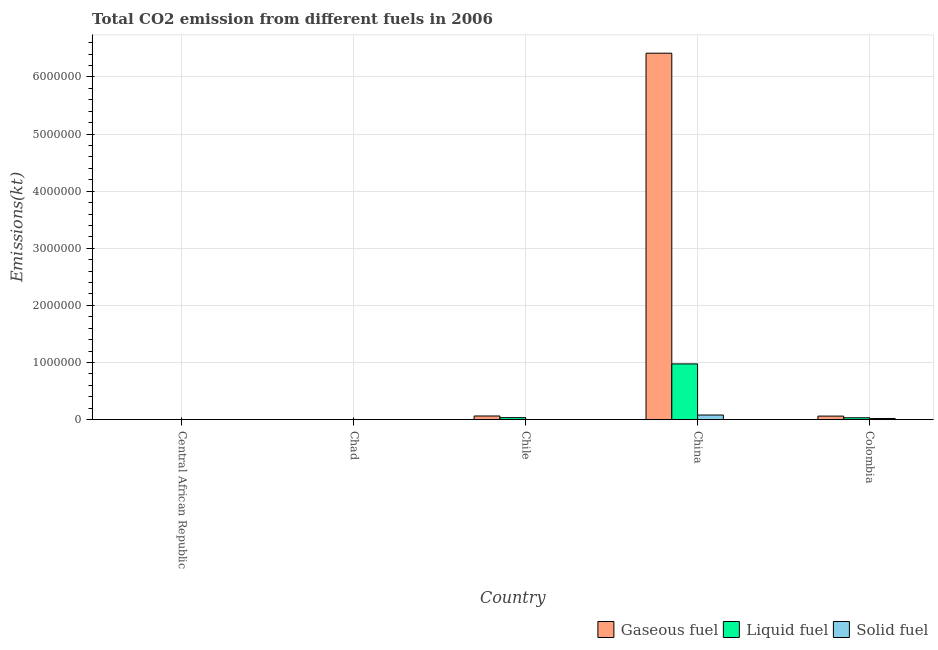How many different coloured bars are there?
Provide a short and direct response. 3. How many groups of bars are there?
Ensure brevity in your answer.  5. Are the number of bars per tick equal to the number of legend labels?
Offer a very short reply. Yes. How many bars are there on the 1st tick from the left?
Give a very brief answer. 3. How many bars are there on the 4th tick from the right?
Make the answer very short. 3. What is the amount of co2 emissions from liquid fuel in Central African Republic?
Give a very brief answer. 227.35. Across all countries, what is the maximum amount of co2 emissions from liquid fuel?
Keep it short and to the point. 9.76e+05. Across all countries, what is the minimum amount of co2 emissions from solid fuel?
Your response must be concise. 25.67. In which country was the amount of co2 emissions from gaseous fuel maximum?
Provide a short and direct response. China. In which country was the amount of co2 emissions from liquid fuel minimum?
Your answer should be compact. Central African Republic. What is the total amount of co2 emissions from liquid fuel in the graph?
Offer a terse response. 1.05e+06. What is the difference between the amount of co2 emissions from liquid fuel in Central African Republic and that in Chad?
Your answer should be very brief. -179.68. What is the difference between the amount of co2 emissions from gaseous fuel in China and the amount of co2 emissions from liquid fuel in Chad?
Offer a very short reply. 6.41e+06. What is the average amount of co2 emissions from solid fuel per country?
Offer a very short reply. 2.11e+04. What is the difference between the amount of co2 emissions from gaseous fuel and amount of co2 emissions from liquid fuel in Chile?
Provide a succinct answer. 2.90e+04. What is the ratio of the amount of co2 emissions from solid fuel in Chad to that in China?
Provide a short and direct response. 0. Is the amount of co2 emissions from solid fuel in Central African Republic less than that in Chile?
Ensure brevity in your answer.  No. What is the difference between the highest and the second highest amount of co2 emissions from gaseous fuel?
Give a very brief answer. 6.35e+06. What is the difference between the highest and the lowest amount of co2 emissions from liquid fuel?
Give a very brief answer. 9.76e+05. Is the sum of the amount of co2 emissions from gaseous fuel in Chad and China greater than the maximum amount of co2 emissions from liquid fuel across all countries?
Your answer should be compact. Yes. What does the 2nd bar from the left in Chile represents?
Ensure brevity in your answer.  Liquid fuel. What does the 3rd bar from the right in Chad represents?
Provide a succinct answer. Gaseous fuel. Is it the case that in every country, the sum of the amount of co2 emissions from gaseous fuel and amount of co2 emissions from liquid fuel is greater than the amount of co2 emissions from solid fuel?
Your response must be concise. No. Are all the bars in the graph horizontal?
Ensure brevity in your answer.  No. What is the difference between two consecutive major ticks on the Y-axis?
Keep it short and to the point. 1.00e+06. Does the graph contain any zero values?
Make the answer very short. No. Where does the legend appear in the graph?
Provide a short and direct response. Bottom right. How are the legend labels stacked?
Your answer should be very brief. Horizontal. What is the title of the graph?
Your answer should be compact. Total CO2 emission from different fuels in 2006. What is the label or title of the Y-axis?
Your response must be concise. Emissions(kt). What is the Emissions(kt) in Gaseous fuel in Central African Republic?
Make the answer very short. 227.35. What is the Emissions(kt) in Liquid fuel in Central African Republic?
Your answer should be very brief. 227.35. What is the Emissions(kt) of Solid fuel in Central African Republic?
Make the answer very short. 2805.26. What is the Emissions(kt) in Gaseous fuel in Chad?
Keep it short and to the point. 407.04. What is the Emissions(kt) in Liquid fuel in Chad?
Give a very brief answer. 407.04. What is the Emissions(kt) of Solid fuel in Chad?
Make the answer very short. 25.67. What is the Emissions(kt) in Gaseous fuel in Chile?
Your answer should be very brief. 6.48e+04. What is the Emissions(kt) of Liquid fuel in Chile?
Keep it short and to the point. 3.58e+04. What is the Emissions(kt) in Solid fuel in Chile?
Make the answer very short. 143.01. What is the Emissions(kt) of Gaseous fuel in China?
Offer a terse response. 6.41e+06. What is the Emissions(kt) in Liquid fuel in China?
Ensure brevity in your answer.  9.76e+05. What is the Emissions(kt) in Solid fuel in China?
Make the answer very short. 8.17e+04. What is the Emissions(kt) in Gaseous fuel in Colombia?
Give a very brief answer. 6.29e+04. What is the Emissions(kt) of Liquid fuel in Colombia?
Make the answer very short. 3.40e+04. What is the Emissions(kt) of Solid fuel in Colombia?
Your response must be concise. 2.10e+04. Across all countries, what is the maximum Emissions(kt) in Gaseous fuel?
Provide a succinct answer. 6.41e+06. Across all countries, what is the maximum Emissions(kt) in Liquid fuel?
Keep it short and to the point. 9.76e+05. Across all countries, what is the maximum Emissions(kt) of Solid fuel?
Offer a very short reply. 8.17e+04. Across all countries, what is the minimum Emissions(kt) in Gaseous fuel?
Ensure brevity in your answer.  227.35. Across all countries, what is the minimum Emissions(kt) in Liquid fuel?
Your response must be concise. 227.35. Across all countries, what is the minimum Emissions(kt) of Solid fuel?
Your answer should be compact. 25.67. What is the total Emissions(kt) of Gaseous fuel in the graph?
Offer a very short reply. 6.54e+06. What is the total Emissions(kt) in Liquid fuel in the graph?
Offer a very short reply. 1.05e+06. What is the total Emissions(kt) of Solid fuel in the graph?
Ensure brevity in your answer.  1.06e+05. What is the difference between the Emissions(kt) in Gaseous fuel in Central African Republic and that in Chad?
Offer a very short reply. -179.68. What is the difference between the Emissions(kt) in Liquid fuel in Central African Republic and that in Chad?
Your answer should be very brief. -179.68. What is the difference between the Emissions(kt) of Solid fuel in Central African Republic and that in Chad?
Provide a succinct answer. 2779.59. What is the difference between the Emissions(kt) in Gaseous fuel in Central African Republic and that in Chile?
Provide a succinct answer. -6.46e+04. What is the difference between the Emissions(kt) in Liquid fuel in Central African Republic and that in Chile?
Your response must be concise. -3.55e+04. What is the difference between the Emissions(kt) of Solid fuel in Central African Republic and that in Chile?
Offer a terse response. 2662.24. What is the difference between the Emissions(kt) in Gaseous fuel in Central African Republic and that in China?
Offer a terse response. -6.41e+06. What is the difference between the Emissions(kt) in Liquid fuel in Central African Republic and that in China?
Make the answer very short. -9.76e+05. What is the difference between the Emissions(kt) in Solid fuel in Central African Republic and that in China?
Keep it short and to the point. -7.89e+04. What is the difference between the Emissions(kt) of Gaseous fuel in Central African Republic and that in Colombia?
Your response must be concise. -6.27e+04. What is the difference between the Emissions(kt) of Liquid fuel in Central African Republic and that in Colombia?
Give a very brief answer. -3.38e+04. What is the difference between the Emissions(kt) in Solid fuel in Central African Republic and that in Colombia?
Provide a short and direct response. -1.82e+04. What is the difference between the Emissions(kt) in Gaseous fuel in Chad and that in Chile?
Make the answer very short. -6.44e+04. What is the difference between the Emissions(kt) in Liquid fuel in Chad and that in Chile?
Your answer should be compact. -3.54e+04. What is the difference between the Emissions(kt) in Solid fuel in Chad and that in Chile?
Offer a terse response. -117.34. What is the difference between the Emissions(kt) of Gaseous fuel in Chad and that in China?
Provide a short and direct response. -6.41e+06. What is the difference between the Emissions(kt) in Liquid fuel in Chad and that in China?
Offer a terse response. -9.76e+05. What is the difference between the Emissions(kt) in Solid fuel in Chad and that in China?
Your response must be concise. -8.17e+04. What is the difference between the Emissions(kt) of Gaseous fuel in Chad and that in Colombia?
Offer a terse response. -6.25e+04. What is the difference between the Emissions(kt) of Liquid fuel in Chad and that in Colombia?
Your answer should be compact. -3.36e+04. What is the difference between the Emissions(kt) in Solid fuel in Chad and that in Colombia?
Give a very brief answer. -2.09e+04. What is the difference between the Emissions(kt) in Gaseous fuel in Chile and that in China?
Make the answer very short. -6.35e+06. What is the difference between the Emissions(kt) in Liquid fuel in Chile and that in China?
Provide a short and direct response. -9.41e+05. What is the difference between the Emissions(kt) of Solid fuel in Chile and that in China?
Keep it short and to the point. -8.16e+04. What is the difference between the Emissions(kt) of Gaseous fuel in Chile and that in Colombia?
Offer a very short reply. 1873.84. What is the difference between the Emissions(kt) in Liquid fuel in Chile and that in Colombia?
Offer a very short reply. 1763.83. What is the difference between the Emissions(kt) in Solid fuel in Chile and that in Colombia?
Your answer should be compact. -2.08e+04. What is the difference between the Emissions(kt) in Gaseous fuel in China and that in Colombia?
Offer a very short reply. 6.35e+06. What is the difference between the Emissions(kt) of Liquid fuel in China and that in Colombia?
Your answer should be compact. 9.42e+05. What is the difference between the Emissions(kt) in Solid fuel in China and that in Colombia?
Make the answer very short. 6.07e+04. What is the difference between the Emissions(kt) in Gaseous fuel in Central African Republic and the Emissions(kt) in Liquid fuel in Chad?
Provide a short and direct response. -179.68. What is the difference between the Emissions(kt) of Gaseous fuel in Central African Republic and the Emissions(kt) of Solid fuel in Chad?
Offer a very short reply. 201.69. What is the difference between the Emissions(kt) of Liquid fuel in Central African Republic and the Emissions(kt) of Solid fuel in Chad?
Provide a short and direct response. 201.69. What is the difference between the Emissions(kt) of Gaseous fuel in Central African Republic and the Emissions(kt) of Liquid fuel in Chile?
Provide a short and direct response. -3.55e+04. What is the difference between the Emissions(kt) of Gaseous fuel in Central African Republic and the Emissions(kt) of Solid fuel in Chile?
Give a very brief answer. 84.34. What is the difference between the Emissions(kt) of Liquid fuel in Central African Republic and the Emissions(kt) of Solid fuel in Chile?
Give a very brief answer. 84.34. What is the difference between the Emissions(kt) of Gaseous fuel in Central African Republic and the Emissions(kt) of Liquid fuel in China?
Provide a short and direct response. -9.76e+05. What is the difference between the Emissions(kt) of Gaseous fuel in Central African Republic and the Emissions(kt) of Solid fuel in China?
Your answer should be compact. -8.15e+04. What is the difference between the Emissions(kt) of Liquid fuel in Central African Republic and the Emissions(kt) of Solid fuel in China?
Provide a short and direct response. -8.15e+04. What is the difference between the Emissions(kt) of Gaseous fuel in Central African Republic and the Emissions(kt) of Liquid fuel in Colombia?
Make the answer very short. -3.38e+04. What is the difference between the Emissions(kt) in Gaseous fuel in Central African Republic and the Emissions(kt) in Solid fuel in Colombia?
Offer a terse response. -2.07e+04. What is the difference between the Emissions(kt) of Liquid fuel in Central African Republic and the Emissions(kt) of Solid fuel in Colombia?
Give a very brief answer. -2.07e+04. What is the difference between the Emissions(kt) of Gaseous fuel in Chad and the Emissions(kt) of Liquid fuel in Chile?
Your answer should be compact. -3.54e+04. What is the difference between the Emissions(kt) in Gaseous fuel in Chad and the Emissions(kt) in Solid fuel in Chile?
Offer a very short reply. 264.02. What is the difference between the Emissions(kt) in Liquid fuel in Chad and the Emissions(kt) in Solid fuel in Chile?
Provide a succinct answer. 264.02. What is the difference between the Emissions(kt) in Gaseous fuel in Chad and the Emissions(kt) in Liquid fuel in China?
Your answer should be compact. -9.76e+05. What is the difference between the Emissions(kt) of Gaseous fuel in Chad and the Emissions(kt) of Solid fuel in China?
Provide a short and direct response. -8.13e+04. What is the difference between the Emissions(kt) in Liquid fuel in Chad and the Emissions(kt) in Solid fuel in China?
Provide a succinct answer. -8.13e+04. What is the difference between the Emissions(kt) in Gaseous fuel in Chad and the Emissions(kt) in Liquid fuel in Colombia?
Make the answer very short. -3.36e+04. What is the difference between the Emissions(kt) in Gaseous fuel in Chad and the Emissions(kt) in Solid fuel in Colombia?
Provide a short and direct response. -2.06e+04. What is the difference between the Emissions(kt) in Liquid fuel in Chad and the Emissions(kt) in Solid fuel in Colombia?
Your answer should be compact. -2.06e+04. What is the difference between the Emissions(kt) in Gaseous fuel in Chile and the Emissions(kt) in Liquid fuel in China?
Give a very brief answer. -9.12e+05. What is the difference between the Emissions(kt) of Gaseous fuel in Chile and the Emissions(kt) of Solid fuel in China?
Make the answer very short. -1.69e+04. What is the difference between the Emissions(kt) of Liquid fuel in Chile and the Emissions(kt) of Solid fuel in China?
Offer a very short reply. -4.59e+04. What is the difference between the Emissions(kt) in Gaseous fuel in Chile and the Emissions(kt) in Liquid fuel in Colombia?
Your answer should be compact. 3.08e+04. What is the difference between the Emissions(kt) of Gaseous fuel in Chile and the Emissions(kt) of Solid fuel in Colombia?
Your answer should be compact. 4.38e+04. What is the difference between the Emissions(kt) of Liquid fuel in Chile and the Emissions(kt) of Solid fuel in Colombia?
Give a very brief answer. 1.48e+04. What is the difference between the Emissions(kt) of Gaseous fuel in China and the Emissions(kt) of Liquid fuel in Colombia?
Offer a very short reply. 6.38e+06. What is the difference between the Emissions(kt) in Gaseous fuel in China and the Emissions(kt) in Solid fuel in Colombia?
Offer a very short reply. 6.39e+06. What is the difference between the Emissions(kt) in Liquid fuel in China and the Emissions(kt) in Solid fuel in Colombia?
Make the answer very short. 9.55e+05. What is the average Emissions(kt) in Gaseous fuel per country?
Ensure brevity in your answer.  1.31e+06. What is the average Emissions(kt) in Liquid fuel per country?
Give a very brief answer. 2.09e+05. What is the average Emissions(kt) of Solid fuel per country?
Your response must be concise. 2.11e+04. What is the difference between the Emissions(kt) in Gaseous fuel and Emissions(kt) in Solid fuel in Central African Republic?
Your answer should be compact. -2577.9. What is the difference between the Emissions(kt) of Liquid fuel and Emissions(kt) of Solid fuel in Central African Republic?
Make the answer very short. -2577.9. What is the difference between the Emissions(kt) in Gaseous fuel and Emissions(kt) in Liquid fuel in Chad?
Keep it short and to the point. 0. What is the difference between the Emissions(kt) in Gaseous fuel and Emissions(kt) in Solid fuel in Chad?
Provide a short and direct response. 381.37. What is the difference between the Emissions(kt) of Liquid fuel and Emissions(kt) of Solid fuel in Chad?
Your response must be concise. 381.37. What is the difference between the Emissions(kt) in Gaseous fuel and Emissions(kt) in Liquid fuel in Chile?
Ensure brevity in your answer.  2.90e+04. What is the difference between the Emissions(kt) of Gaseous fuel and Emissions(kt) of Solid fuel in Chile?
Your answer should be compact. 6.47e+04. What is the difference between the Emissions(kt) in Liquid fuel and Emissions(kt) in Solid fuel in Chile?
Keep it short and to the point. 3.56e+04. What is the difference between the Emissions(kt) in Gaseous fuel and Emissions(kt) in Liquid fuel in China?
Give a very brief answer. 5.44e+06. What is the difference between the Emissions(kt) in Gaseous fuel and Emissions(kt) in Solid fuel in China?
Provide a succinct answer. 6.33e+06. What is the difference between the Emissions(kt) of Liquid fuel and Emissions(kt) of Solid fuel in China?
Provide a short and direct response. 8.95e+05. What is the difference between the Emissions(kt) of Gaseous fuel and Emissions(kt) of Liquid fuel in Colombia?
Your answer should be compact. 2.89e+04. What is the difference between the Emissions(kt) of Gaseous fuel and Emissions(kt) of Solid fuel in Colombia?
Your response must be concise. 4.20e+04. What is the difference between the Emissions(kt) of Liquid fuel and Emissions(kt) of Solid fuel in Colombia?
Offer a terse response. 1.30e+04. What is the ratio of the Emissions(kt) in Gaseous fuel in Central African Republic to that in Chad?
Ensure brevity in your answer.  0.56. What is the ratio of the Emissions(kt) in Liquid fuel in Central African Republic to that in Chad?
Provide a succinct answer. 0.56. What is the ratio of the Emissions(kt) of Solid fuel in Central African Republic to that in Chad?
Ensure brevity in your answer.  109.29. What is the ratio of the Emissions(kt) in Gaseous fuel in Central African Republic to that in Chile?
Ensure brevity in your answer.  0. What is the ratio of the Emissions(kt) in Liquid fuel in Central African Republic to that in Chile?
Provide a short and direct response. 0.01. What is the ratio of the Emissions(kt) in Solid fuel in Central African Republic to that in Chile?
Give a very brief answer. 19.62. What is the ratio of the Emissions(kt) in Gaseous fuel in Central African Republic to that in China?
Offer a very short reply. 0. What is the ratio of the Emissions(kt) of Liquid fuel in Central African Republic to that in China?
Provide a succinct answer. 0. What is the ratio of the Emissions(kt) of Solid fuel in Central African Republic to that in China?
Your response must be concise. 0.03. What is the ratio of the Emissions(kt) in Gaseous fuel in Central African Republic to that in Colombia?
Provide a succinct answer. 0. What is the ratio of the Emissions(kt) of Liquid fuel in Central African Republic to that in Colombia?
Provide a short and direct response. 0.01. What is the ratio of the Emissions(kt) of Solid fuel in Central African Republic to that in Colombia?
Offer a terse response. 0.13. What is the ratio of the Emissions(kt) in Gaseous fuel in Chad to that in Chile?
Offer a very short reply. 0.01. What is the ratio of the Emissions(kt) in Liquid fuel in Chad to that in Chile?
Your answer should be very brief. 0.01. What is the ratio of the Emissions(kt) in Solid fuel in Chad to that in Chile?
Give a very brief answer. 0.18. What is the ratio of the Emissions(kt) in Liquid fuel in Chad to that in China?
Provide a short and direct response. 0. What is the ratio of the Emissions(kt) in Solid fuel in Chad to that in China?
Provide a short and direct response. 0. What is the ratio of the Emissions(kt) of Gaseous fuel in Chad to that in Colombia?
Your response must be concise. 0.01. What is the ratio of the Emissions(kt) of Liquid fuel in Chad to that in Colombia?
Make the answer very short. 0.01. What is the ratio of the Emissions(kt) in Solid fuel in Chad to that in Colombia?
Keep it short and to the point. 0. What is the ratio of the Emissions(kt) of Gaseous fuel in Chile to that in China?
Keep it short and to the point. 0.01. What is the ratio of the Emissions(kt) of Liquid fuel in Chile to that in China?
Keep it short and to the point. 0.04. What is the ratio of the Emissions(kt) in Solid fuel in Chile to that in China?
Offer a terse response. 0. What is the ratio of the Emissions(kt) of Gaseous fuel in Chile to that in Colombia?
Provide a succinct answer. 1.03. What is the ratio of the Emissions(kt) of Liquid fuel in Chile to that in Colombia?
Provide a succinct answer. 1.05. What is the ratio of the Emissions(kt) of Solid fuel in Chile to that in Colombia?
Your answer should be compact. 0.01. What is the ratio of the Emissions(kt) of Gaseous fuel in China to that in Colombia?
Provide a short and direct response. 101.91. What is the ratio of the Emissions(kt) of Liquid fuel in China to that in Colombia?
Your answer should be very brief. 28.72. What is the ratio of the Emissions(kt) of Solid fuel in China to that in Colombia?
Offer a very short reply. 3.9. What is the difference between the highest and the second highest Emissions(kt) in Gaseous fuel?
Offer a terse response. 6.35e+06. What is the difference between the highest and the second highest Emissions(kt) of Liquid fuel?
Your response must be concise. 9.41e+05. What is the difference between the highest and the second highest Emissions(kt) of Solid fuel?
Your answer should be very brief. 6.07e+04. What is the difference between the highest and the lowest Emissions(kt) of Gaseous fuel?
Offer a terse response. 6.41e+06. What is the difference between the highest and the lowest Emissions(kt) in Liquid fuel?
Your response must be concise. 9.76e+05. What is the difference between the highest and the lowest Emissions(kt) of Solid fuel?
Ensure brevity in your answer.  8.17e+04. 